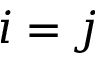<formula> <loc_0><loc_0><loc_500><loc_500>i = j</formula> 